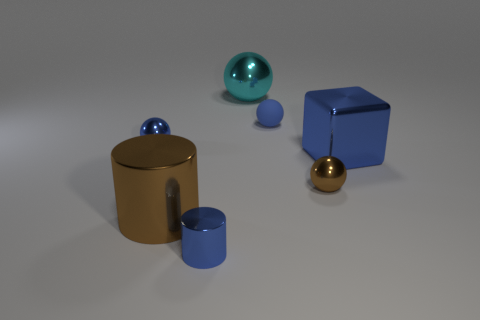Subtract 1 balls. How many balls are left? 3 Add 2 tiny blue things. How many objects exist? 9 Subtract all blocks. How many objects are left? 6 Subtract all cyan things. Subtract all red cubes. How many objects are left? 6 Add 7 cyan balls. How many cyan balls are left? 8 Add 6 cyan shiny things. How many cyan shiny things exist? 7 Subtract 0 yellow balls. How many objects are left? 7 